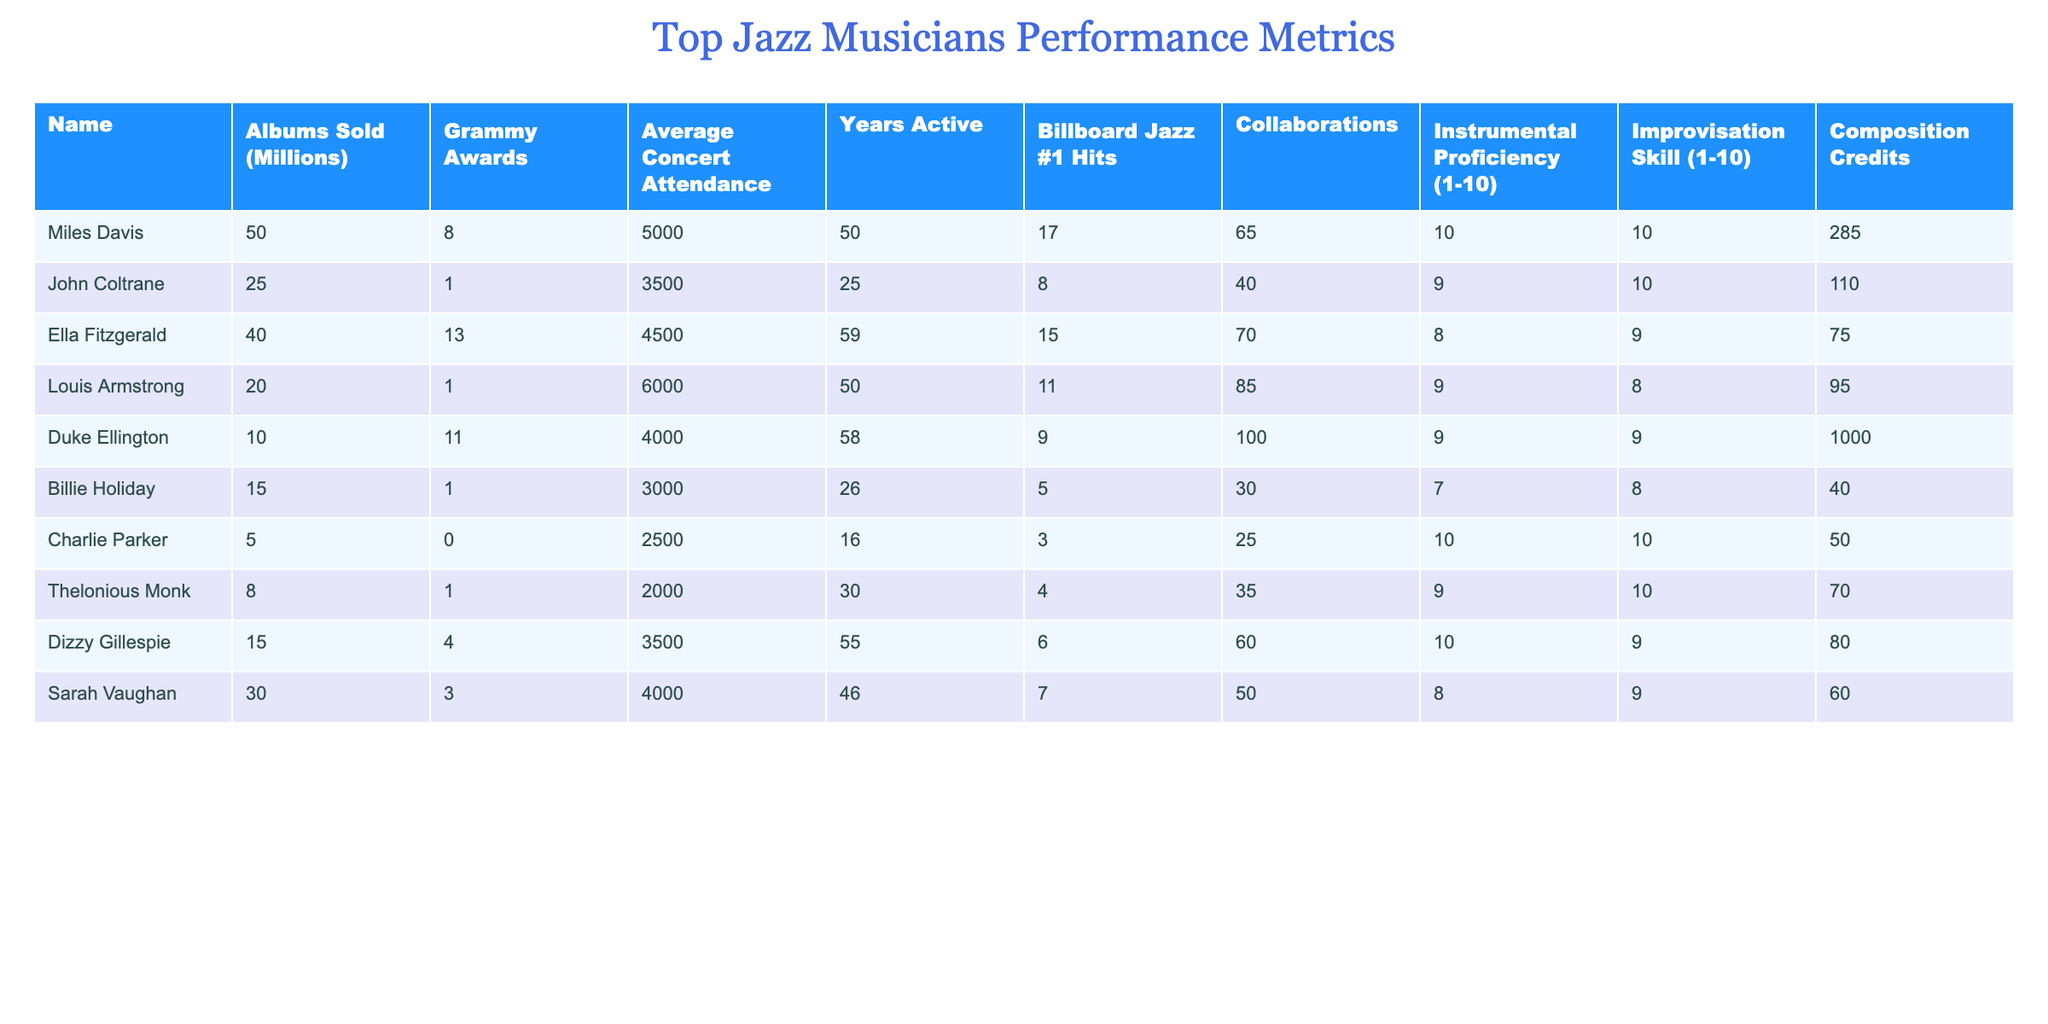What is the total number of Grammy Awards won by the musicians in the table? To find the total number of Grammy Awards, I will sum the Grammy Awards column values: 8 + 1 + 13 + 1 + 11 + 1 + 0 + 1 + 4 + 3 = 43.
Answer: 43 Which musician has the highest average concert attendance? Looking at the Average Concert Attendance column, I see that Louis Armstrong has the highest value at 6000.
Answer: Louis Armstrong What is the average number of albums sold across all musicians? To find the average, I will sum the Albums Sold column: 50 + 25 + 40 + 20 + 10 + 15 + 5 + 8 + 15 + 30 = 218. There are 10 musicians, so the average is 218 / 10 = 21.8 million.
Answer: 21.8 million Did Miles Davis have more Billboard Jazz #1 Hits than Ella Fitzgerald? Miles Davis has 17 Billboard Jazz #1 Hits while Ella Fitzgerald has 15. Since 17 is greater than 15, the answer is yes.
Answer: Yes Which musician has the best improvisation skill rating and how many compositions did they write? The highest Improvisation Skill rating is 10, which belongs to both Miles Davis and Charlie Parker. Miles Davis has 285 composition credits, while Charlie Parker has 50.
Answer: Miles Davis with 285 How many musicians have an Instrumental Proficiency rating of 9 or higher? By checking the Instrumental Proficiency ratings, I find that Miles Davis, John Coltrane, Ella Fitzgerald, Louis Armstrong, Duke Ellington, Dizzy Gillespie, and Thelonious Monk have ratings of 9 or higher. This totals to 7 musicians.
Answer: 7 What is the difference between the average concert attendance of the top musician and the musician with the lowest attendance? The musician with the highest attendance is Louis Armstrong with 6000, and the lowest is Thelonious Monk with 2000. The difference is 6000 - 2000 = 4000.
Answer: 4000 Is it true that Sarah Vaughan has more Collaboration credits than Billie Holiday? Sarah Vaughan has 50 collaboration credits, while Billie Holiday has 30. Since 50 is greater than 30, the statement is true.
Answer: True What percentage of the total Albums Sold (across all musicians) was sold by Miles Davis? To find the percentage, I will first find the total albums sold which is 218 million. Then, Miles Davis sold 50 million. The percentage is (50 / 218) * 100 = approximately 22.94%.
Answer: 22.94% 